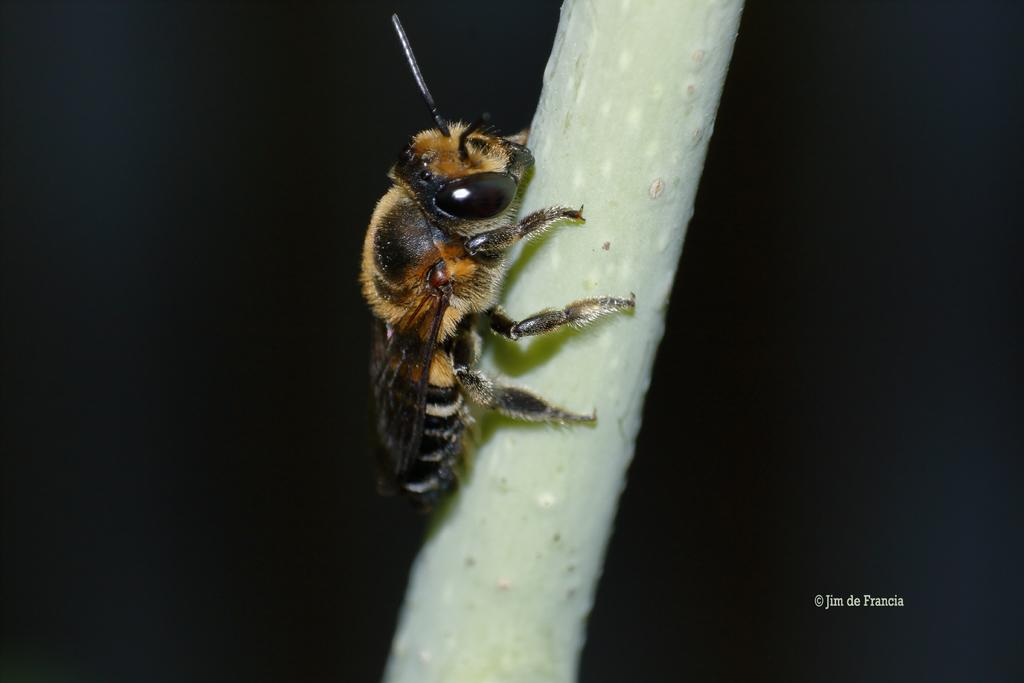What is the main subject of the image? There is an insect in the center of the image. What type of tree is the insect using as a partner in the image? There is no tree or partner present in the image; it only features an insect. 